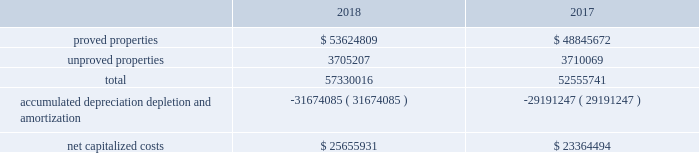Eog resources , inc .
Supplemental information to consolidated financial statements ( continued ) capitalized costs relating to oil and gas producing activities .
The table sets forth the capitalized costs relating to eog's crude oil and natural gas producing activities at december 31 , 2018 and 2017: .
Costs incurred in oil and gas property acquisition , exploration and development activities .
The acquisition , exploration and development costs disclosed in the following tables are in accordance with definitions in the extractive industries - oil and gas topic of the accounting standards codification ( asc ) .
Acquisition costs include costs incurred to purchase , lease or otherwise acquire property .
Exploration costs include additions to exploratory wells , including those in progress , and exploration expenses .
Development costs include additions to production facilities and equipment and additions to development wells , including those in progress. .
Considering the years 2017 and 2018 , what was the increase observed in the net capitalized costs? 
Rationale: it is the value of the net capitalized costs of 2018 divided by the 2017's , then subtracted 1 and turned into a percentage .
Computations: ((25655931 / 23364494) - 1)
Answer: 0.09807. 